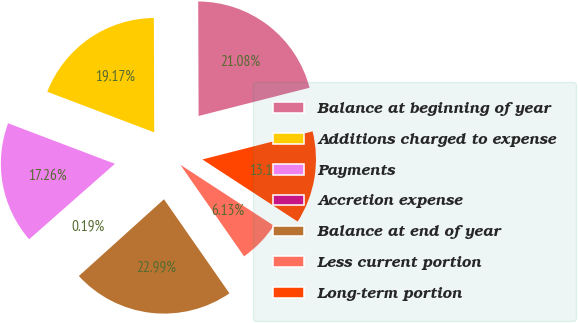<chart> <loc_0><loc_0><loc_500><loc_500><pie_chart><fcel>Balance at beginning of year<fcel>Additions charged to expense<fcel>Payments<fcel>Accretion expense<fcel>Balance at end of year<fcel>Less current portion<fcel>Long-term portion<nl><fcel>21.08%<fcel>19.17%<fcel>17.26%<fcel>0.19%<fcel>22.99%<fcel>6.13%<fcel>13.16%<nl></chart> 